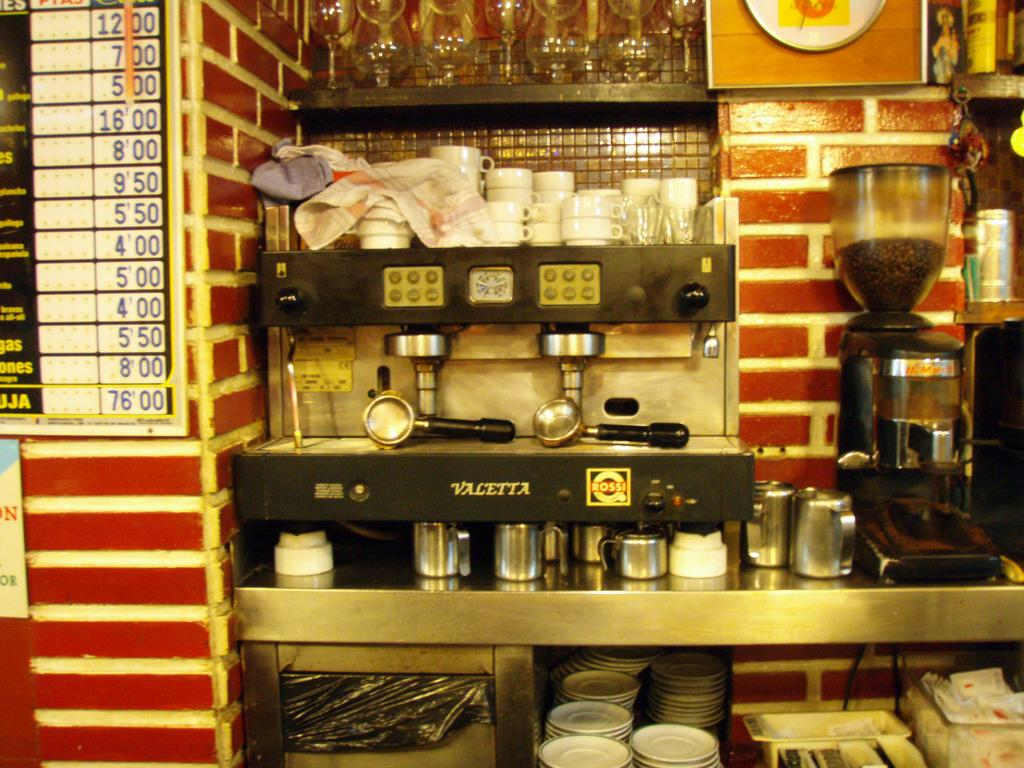<image>
Write a terse but informative summary of the picture. A coffee maker made my Valetta with cups by it. 